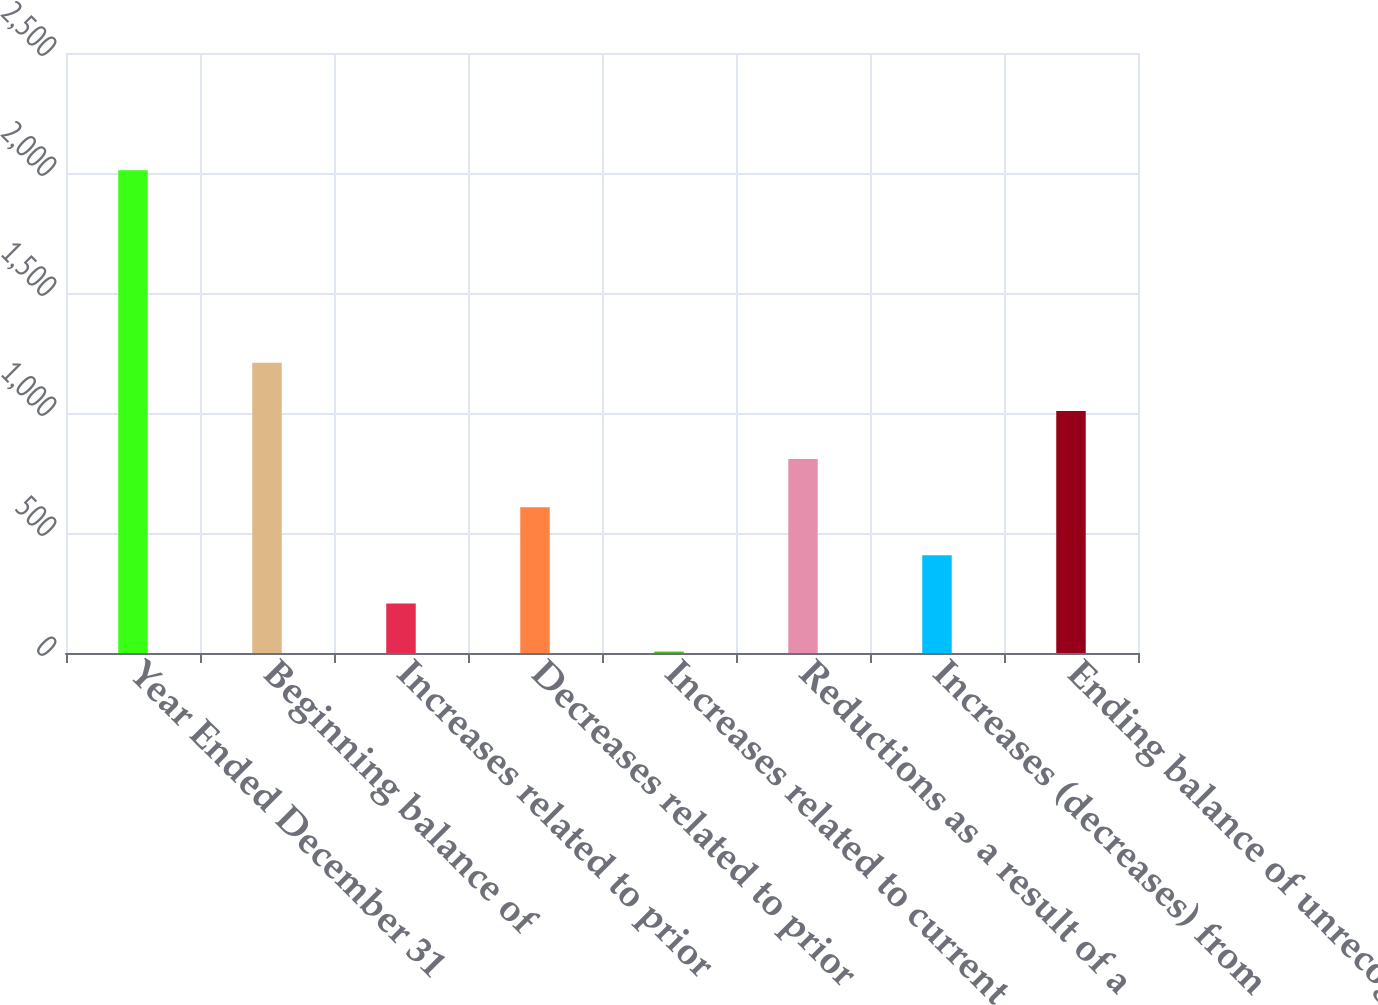<chart> <loc_0><loc_0><loc_500><loc_500><bar_chart><fcel>Year Ended December 31<fcel>Beginning balance of<fcel>Increases related to prior<fcel>Decreases related to prior<fcel>Increases related to current<fcel>Reductions as a result of a<fcel>Increases (decreases) from<fcel>Ending balance of unrecognized<nl><fcel>2011<fcel>1209<fcel>206.5<fcel>607.5<fcel>6<fcel>808<fcel>407<fcel>1008.5<nl></chart> 